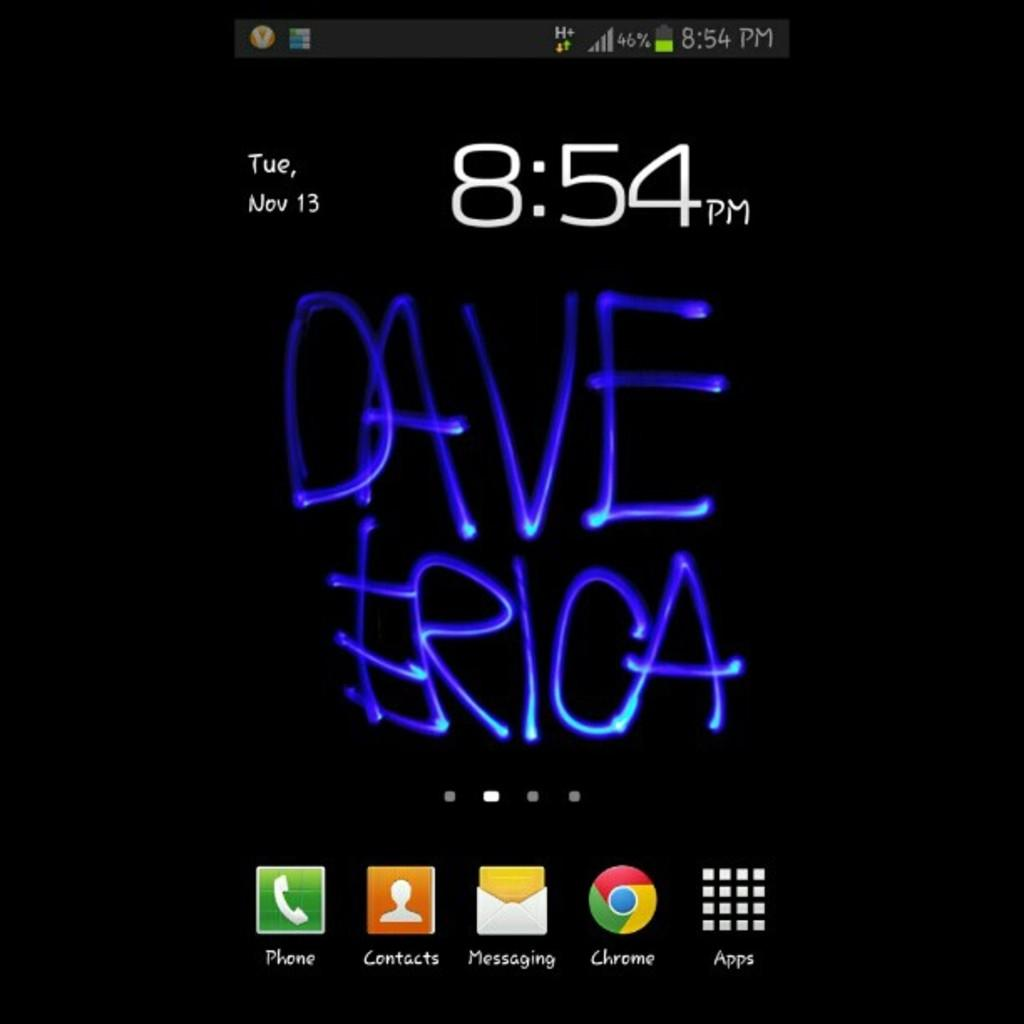<image>
Share a concise interpretation of the image provided. Digital writing with the names Dave and Erica written in blue 